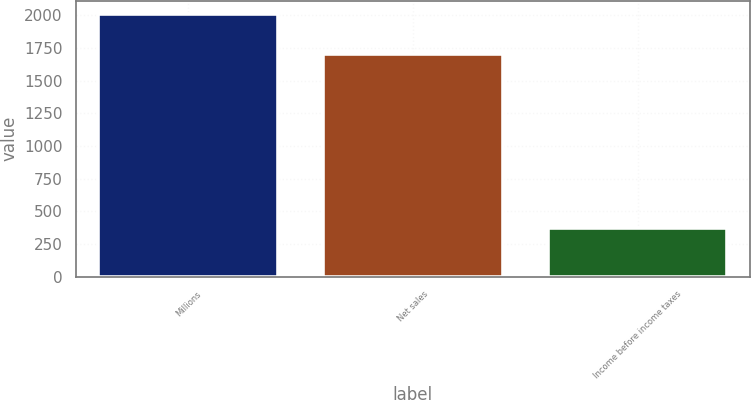Convert chart. <chart><loc_0><loc_0><loc_500><loc_500><bar_chart><fcel>Millions<fcel>Net sales<fcel>Income before income taxes<nl><fcel>2012<fcel>1700<fcel>368<nl></chart> 